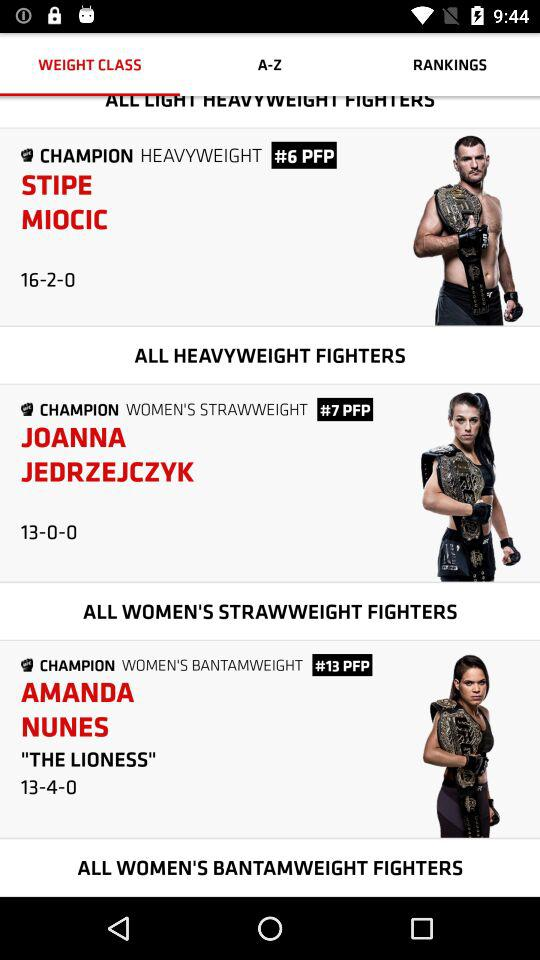What does the #13 PFP mean next to Amanda Nunes' name in this listing? The '#13 PFP' next to Amanda Nunes' name indicates her rank as the 13th fighter in the pound-for-pound (PFP) rankings across all divisions and genders within the UFC, highlighting her exceptional skills and success relative to fighters of different weights. 